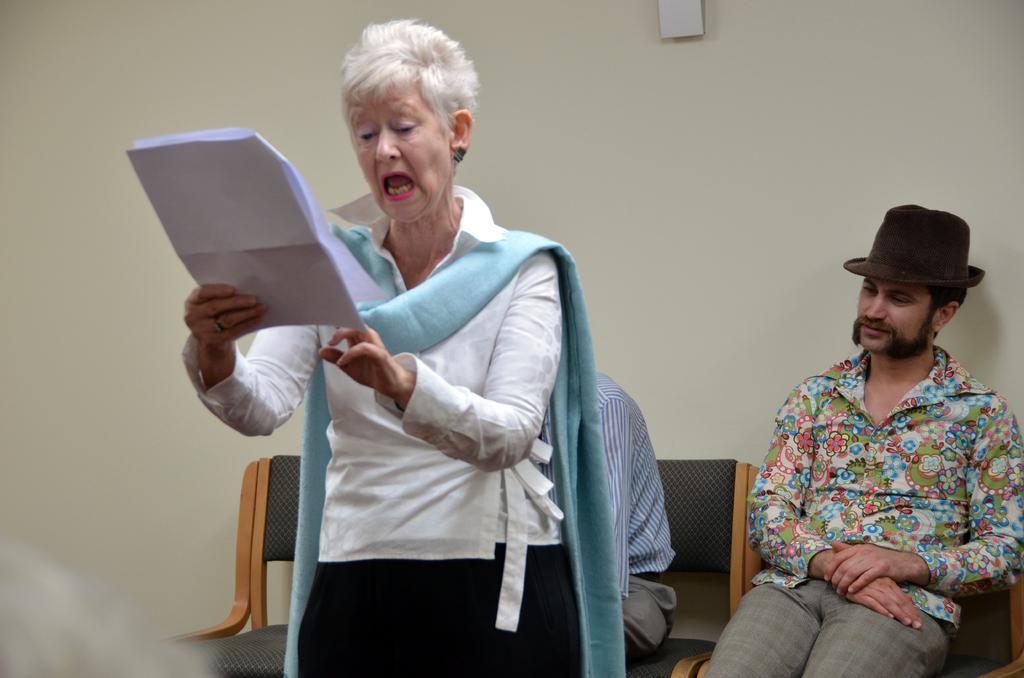Can you describe this image briefly? In this image I can see a person wearing white, blue and black colored dress is standing and holding few papers in hands. In the background I can see few persons sitting on chairs and the cream colored wall. 